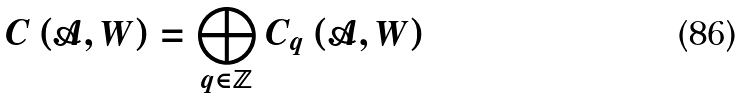Convert formula to latex. <formula><loc_0><loc_0><loc_500><loc_500>C \left ( \mathcal { A } , W \right ) = \bigoplus _ { q \in \mathbb { Z } } C _ { q } \left ( \mathcal { A } , W \right )</formula> 